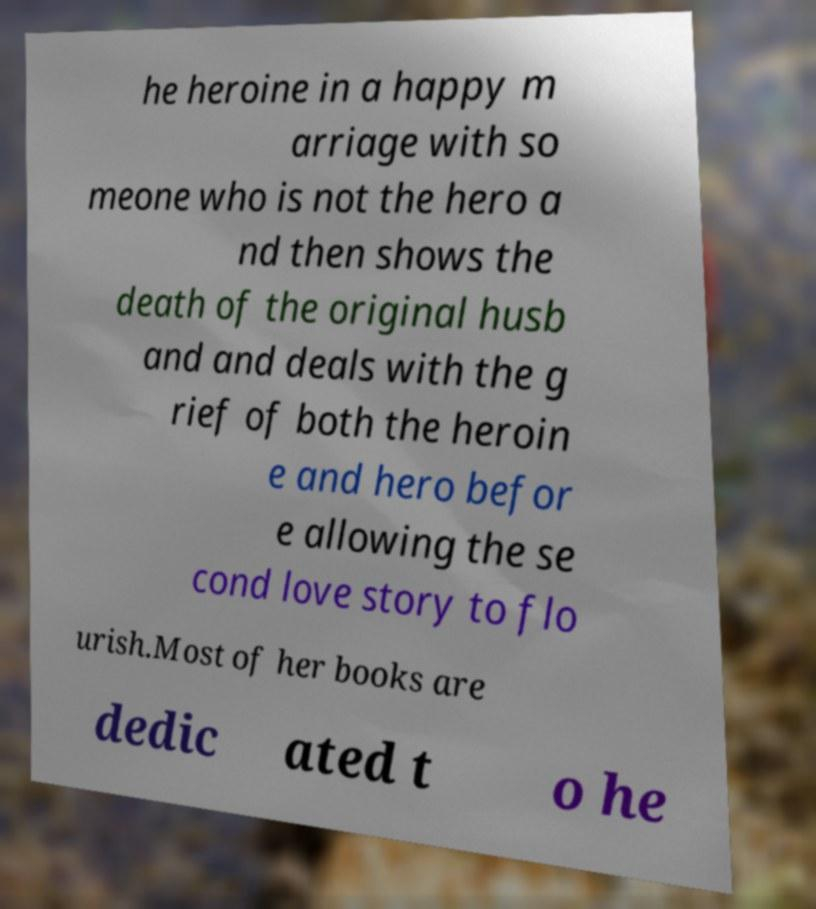Could you extract and type out the text from this image? he heroine in a happy m arriage with so meone who is not the hero a nd then shows the death of the original husb and and deals with the g rief of both the heroin e and hero befor e allowing the se cond love story to flo urish.Most of her books are dedic ated t o he 